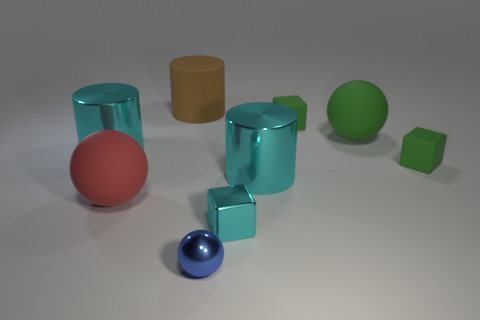Add 1 small cubes. How many objects exist? 10 Subtract all spheres. How many objects are left? 6 Subtract all tiny cyan metallic objects. Subtract all shiny balls. How many objects are left? 7 Add 5 large red matte objects. How many large red matte objects are left? 6 Add 7 big cyan rubber cylinders. How many big cyan rubber cylinders exist? 7 Subtract 1 blue balls. How many objects are left? 8 